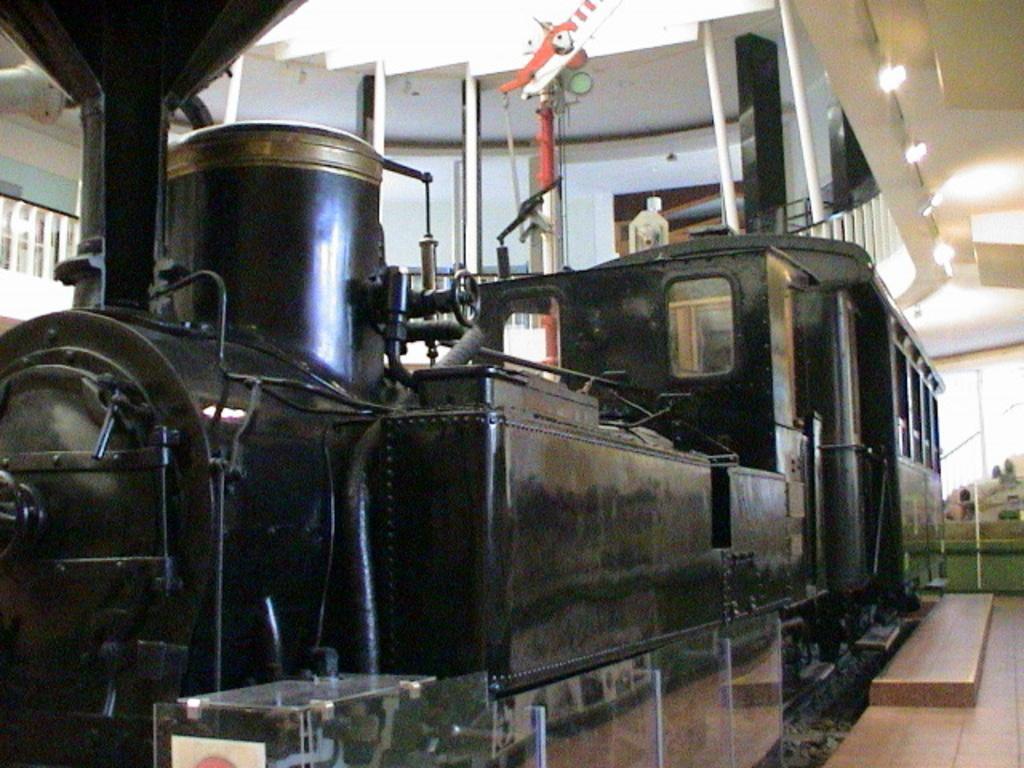Can you describe this image briefly? In this image we can see a train engine which is in black color. 